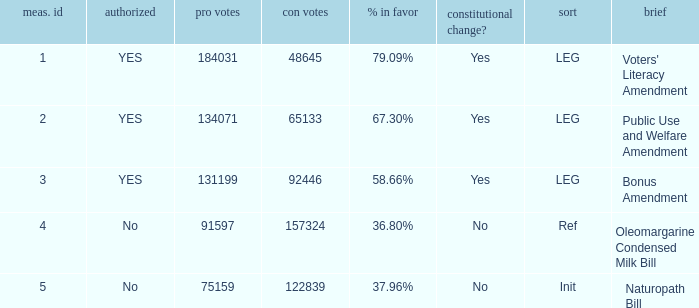What is the measure number for the init type?  5.0. 